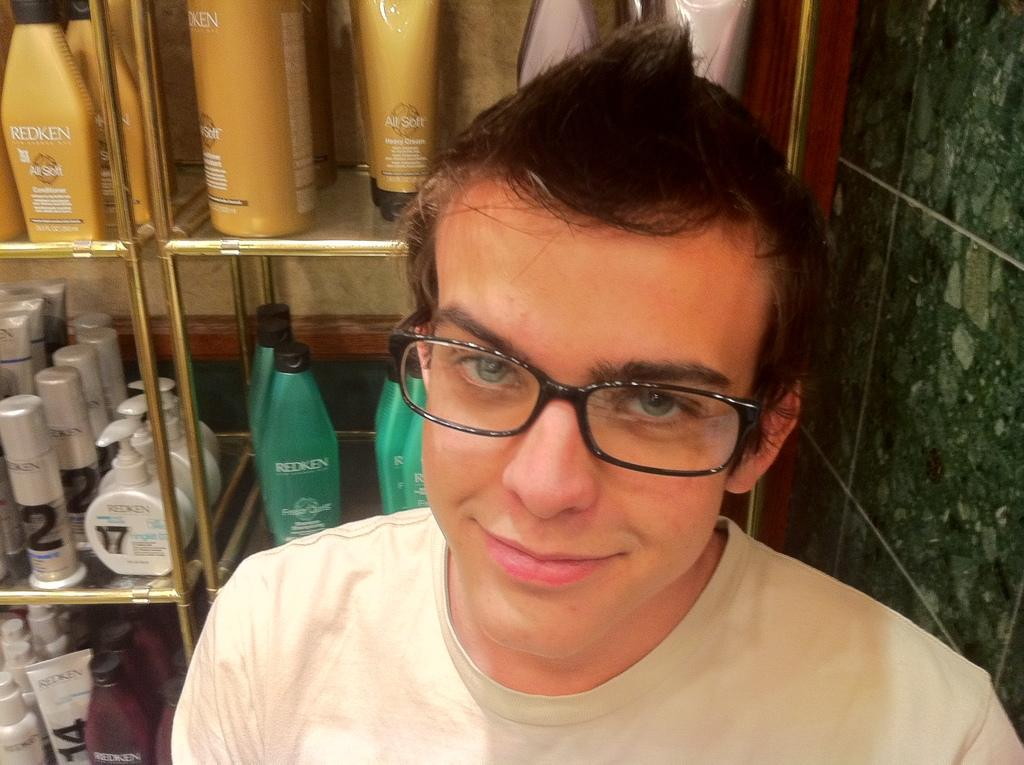Provide a one-sentence caption for the provided image. A man standing in front of shelves displaying Redken products. 